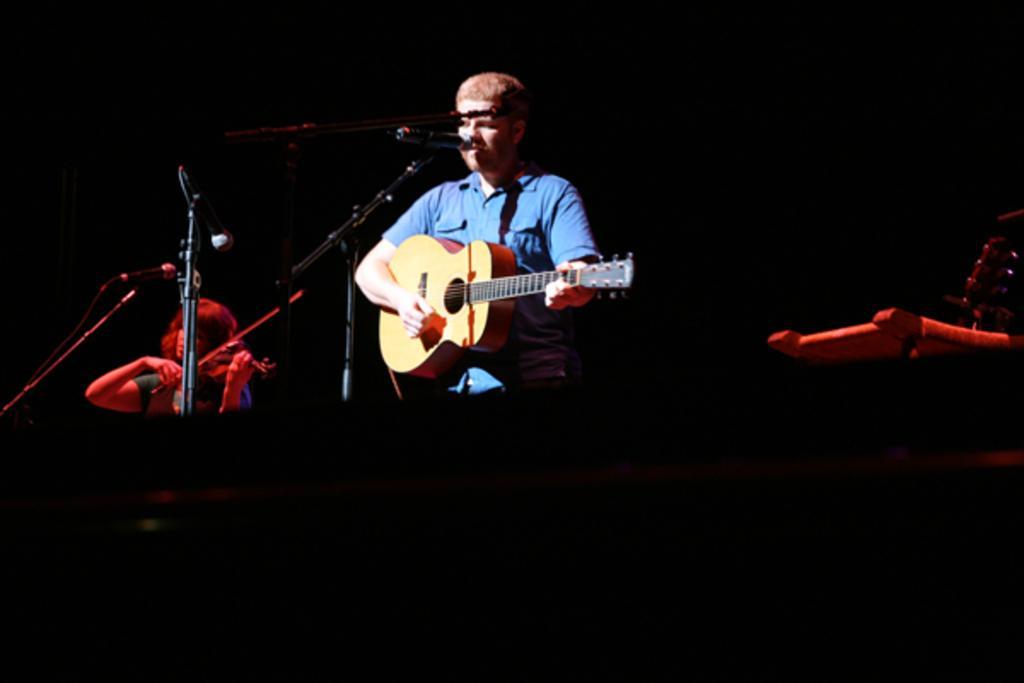How would you summarize this image in a sentence or two? In this image there is a person wearing blue color shirt playing guitar in front of him there is a microphone at the left side of the image there is a woman playing violin in front of her there is a microphone and at the background there is a dark black color. 